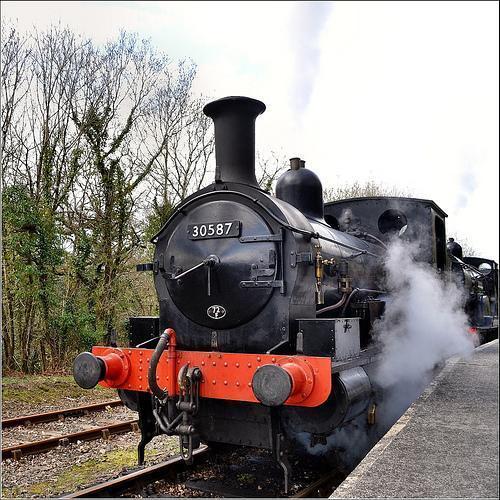How many trains?
Give a very brief answer. 1. 